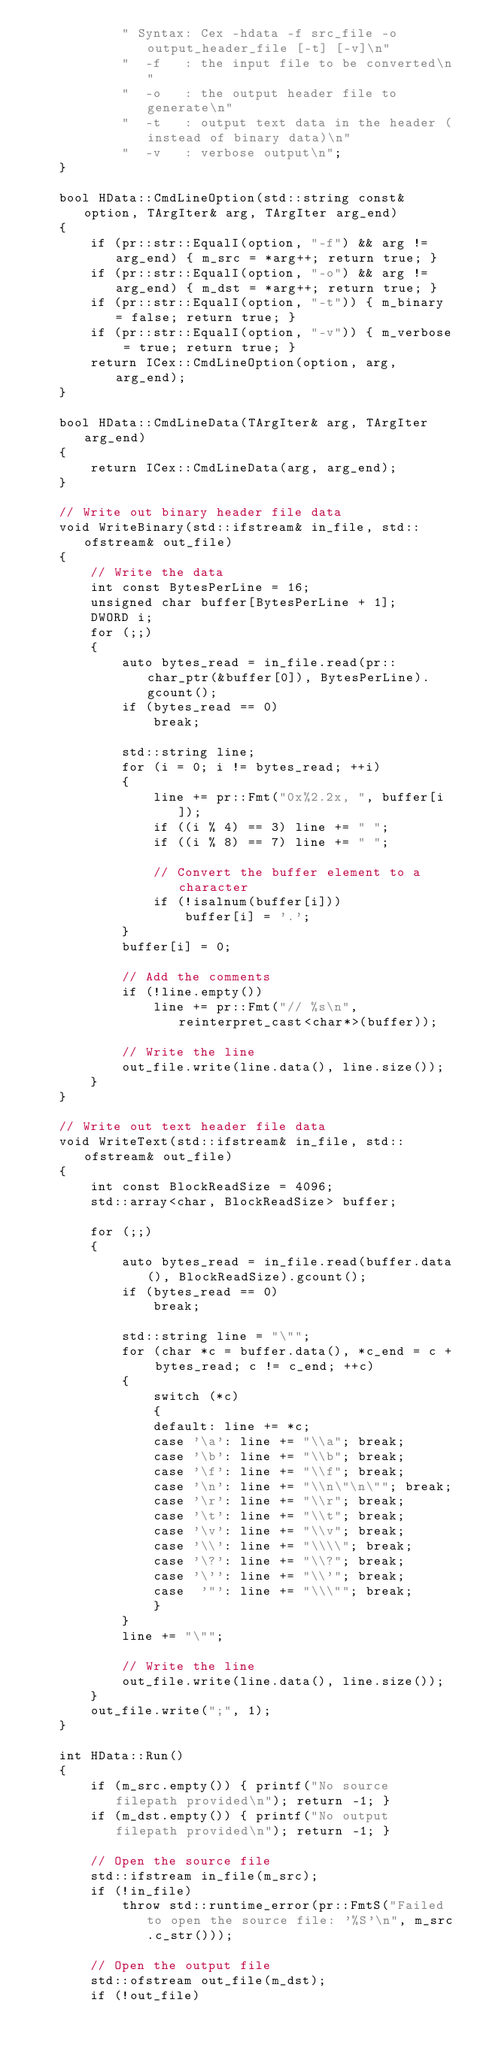Convert code to text. <code><loc_0><loc_0><loc_500><loc_500><_C++_>			" Syntax: Cex -hdata -f src_file -o output_header_file [-t] [-v]\n"
			"  -f   : the input file to be converted\n"
			"  -o   : the output header file to generate\n"
			"  -t   : output text data in the header (instead of binary data)\n"
			"  -v   : verbose output\n";
	}

	bool HData::CmdLineOption(std::string const& option, TArgIter& arg, TArgIter arg_end)
	{
		if (pr::str::EqualI(option, "-f") && arg != arg_end) { m_src = *arg++; return true; }
		if (pr::str::EqualI(option, "-o") && arg != arg_end) { m_dst = *arg++; return true; }
		if (pr::str::EqualI(option, "-t")) { m_binary = false; return true; }
		if (pr::str::EqualI(option, "-v")) { m_verbose = true; return true; }
		return ICex::CmdLineOption(option, arg, arg_end);
	}

	bool HData::CmdLineData(TArgIter& arg, TArgIter arg_end)
	{
		return ICex::CmdLineData(arg, arg_end);
	}

	// Write out binary header file data
	void WriteBinary(std::ifstream& in_file, std::ofstream& out_file)
	{
		// Write the data
		int const BytesPerLine = 16;
		unsigned char buffer[BytesPerLine + 1];
		DWORD i;
		for (;;)
		{
			auto bytes_read = in_file.read(pr::char_ptr(&buffer[0]), BytesPerLine).gcount();
			if (bytes_read == 0)
				break;

			std::string line;
			for (i = 0; i != bytes_read; ++i)
			{
				line += pr::Fmt("0x%2.2x, ", buffer[i]);
				if ((i % 4) == 3) line += " ";
				if ((i % 8) == 7) line += " ";

				// Convert the buffer element to a character
				if (!isalnum(buffer[i]))
					buffer[i] = '.';
			}
			buffer[i] = 0;

			// Add the comments
			if (!line.empty())
				line += pr::Fmt("// %s\n", reinterpret_cast<char*>(buffer));

			// Write the line
			out_file.write(line.data(), line.size());
		}
	}

	// Write out text header file data
	void WriteText(std::ifstream& in_file, std::ofstream& out_file)
	{
		int const BlockReadSize = 4096;
		std::array<char, BlockReadSize> buffer;

		for (;;)
		{
			auto bytes_read = in_file.read(buffer.data(), BlockReadSize).gcount();
			if (bytes_read == 0)
				break;

			std::string line = "\"";
			for (char *c = buffer.data(), *c_end = c + bytes_read; c != c_end; ++c)
			{
				switch (*c)
				{
				default: line += *c;
				case '\a': line += "\\a"; break;
				case '\b': line += "\\b"; break;
				case '\f': line += "\\f"; break;
				case '\n': line += "\\n\"\n\""; break;
				case '\r': line += "\\r"; break;
				case '\t': line += "\\t"; break;
				case '\v': line += "\\v"; break;
				case '\\': line += "\\\\"; break;
				case '\?': line += "\\?"; break;
				case '\'': line += "\\'"; break;
				case  '"': line += "\\\""; break;
				}
			}
			line += "\"";

			// Write the line
			out_file.write(line.data(), line.size());
		}
		out_file.write(";", 1);
	}

	int HData::Run()
	{
		if (m_src.empty()) { printf("No source filepath provided\n"); return -1; }
		if (m_dst.empty()) { printf("No output filepath provided\n"); return -1; }

		// Open the source file
		std::ifstream in_file(m_src);
		if (!in_file)
			throw std::runtime_error(pr::FmtS("Failed to open the source file: '%S'\n", m_src.c_str()));

		// Open the output file
		std::ofstream out_file(m_dst);
		if (!out_file)</code> 